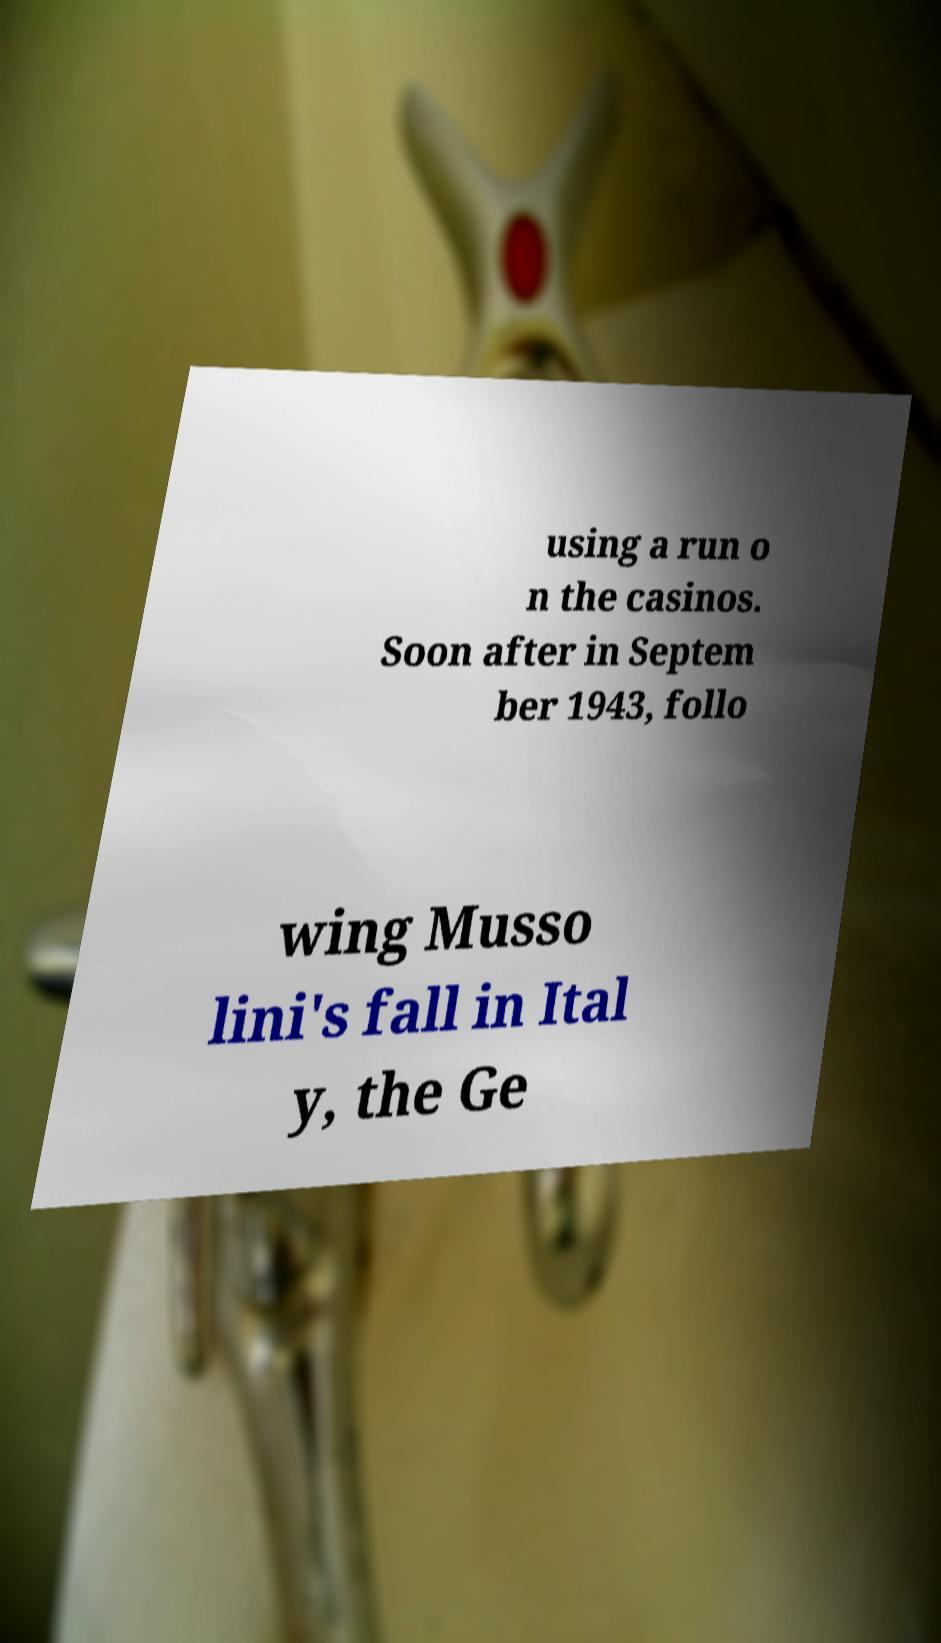Could you extract and type out the text from this image? using a run o n the casinos. Soon after in Septem ber 1943, follo wing Musso lini's fall in Ital y, the Ge 